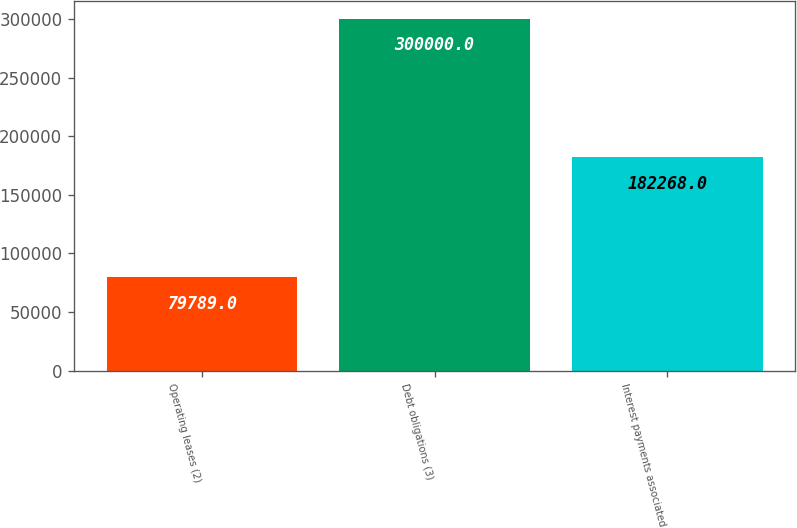Convert chart. <chart><loc_0><loc_0><loc_500><loc_500><bar_chart><fcel>Operating leases (2)<fcel>Debt obligations (3)<fcel>Interest payments associated<nl><fcel>79789<fcel>300000<fcel>182268<nl></chart> 